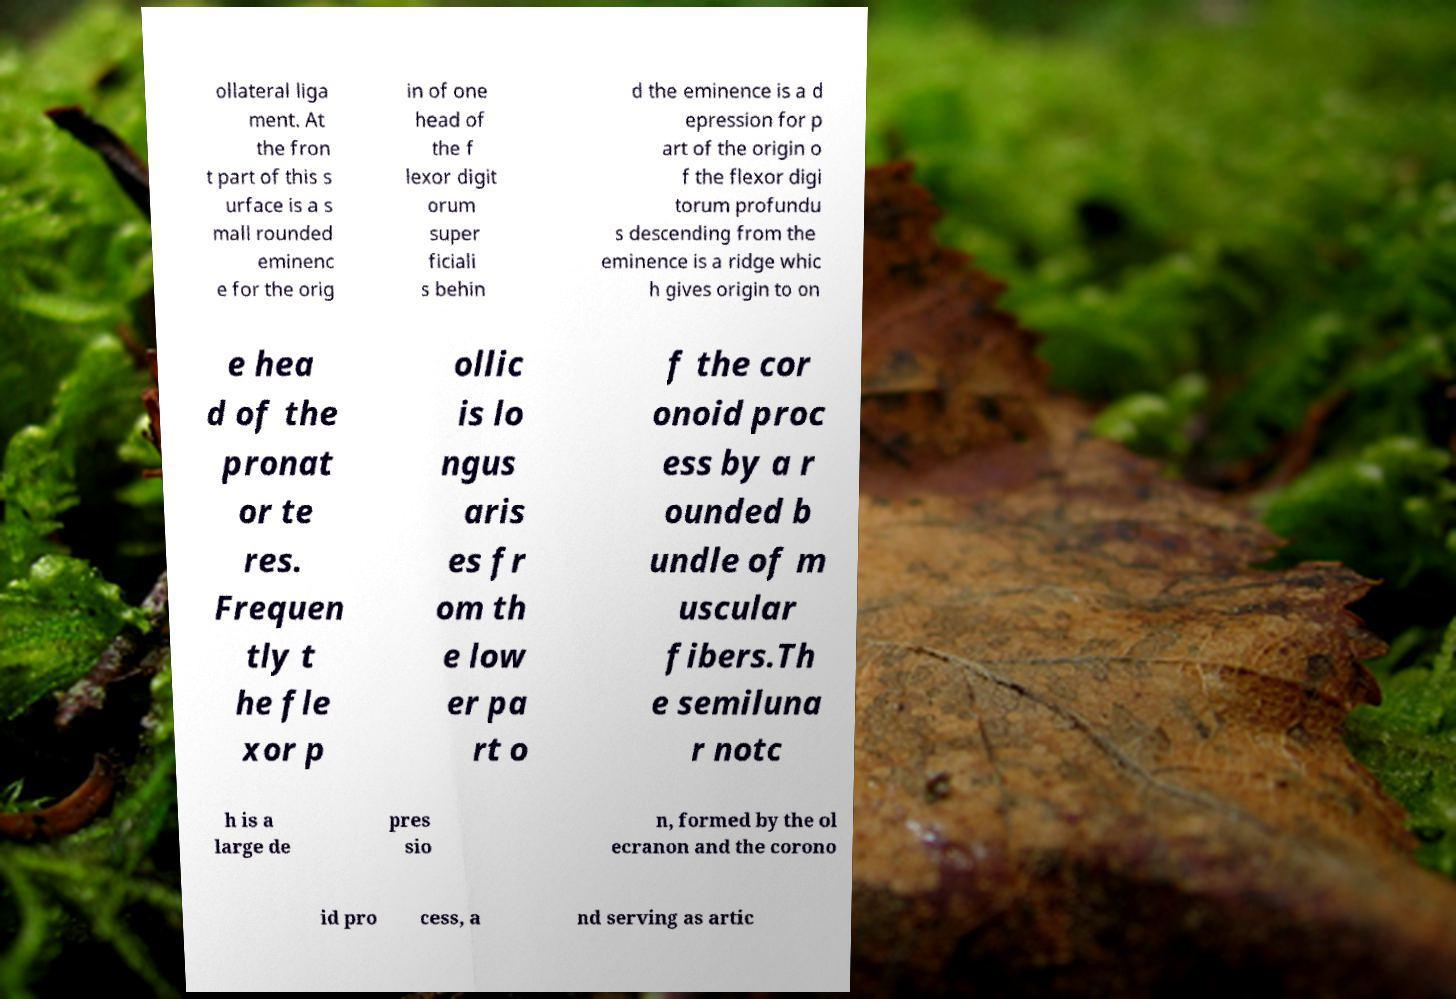Please identify and transcribe the text found in this image. ollateral liga ment. At the fron t part of this s urface is a s mall rounded eminenc e for the orig in of one head of the f lexor digit orum super ficiali s behin d the eminence is a d epression for p art of the origin o f the flexor digi torum profundu s descending from the eminence is a ridge whic h gives origin to on e hea d of the pronat or te res. Frequen tly t he fle xor p ollic is lo ngus aris es fr om th e low er pa rt o f the cor onoid proc ess by a r ounded b undle of m uscular fibers.Th e semiluna r notc h is a large de pres sio n, formed by the ol ecranon and the corono id pro cess, a nd serving as artic 